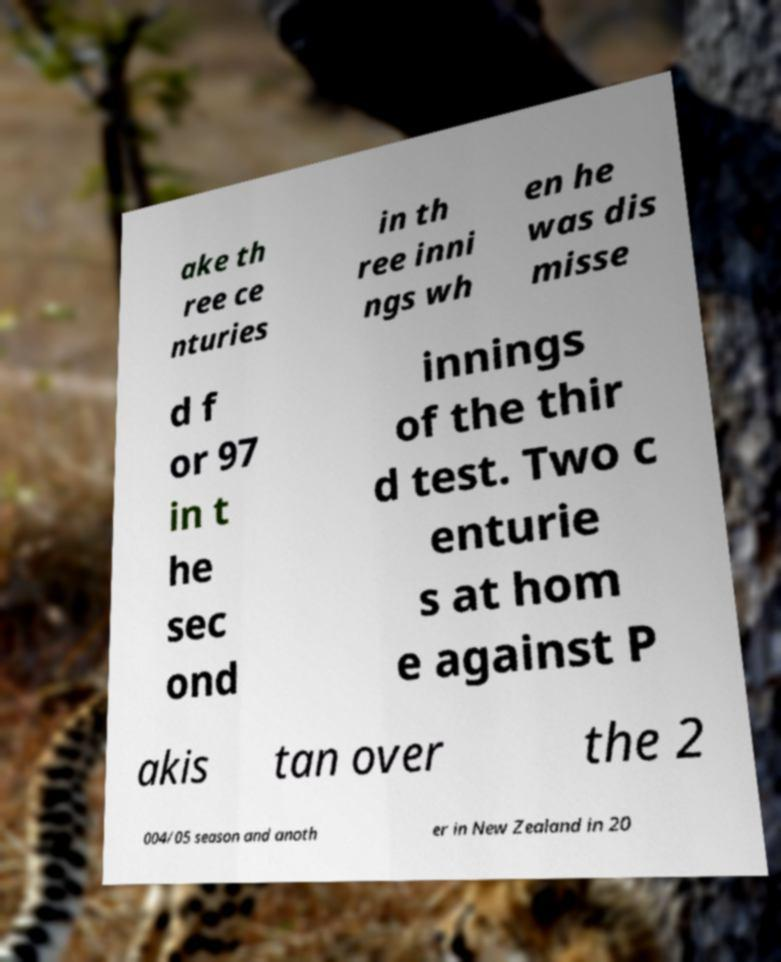I need the written content from this picture converted into text. Can you do that? ake th ree ce nturies in th ree inni ngs wh en he was dis misse d f or 97 in t he sec ond innings of the thir d test. Two c enturie s at hom e against P akis tan over the 2 004/05 season and anoth er in New Zealand in 20 